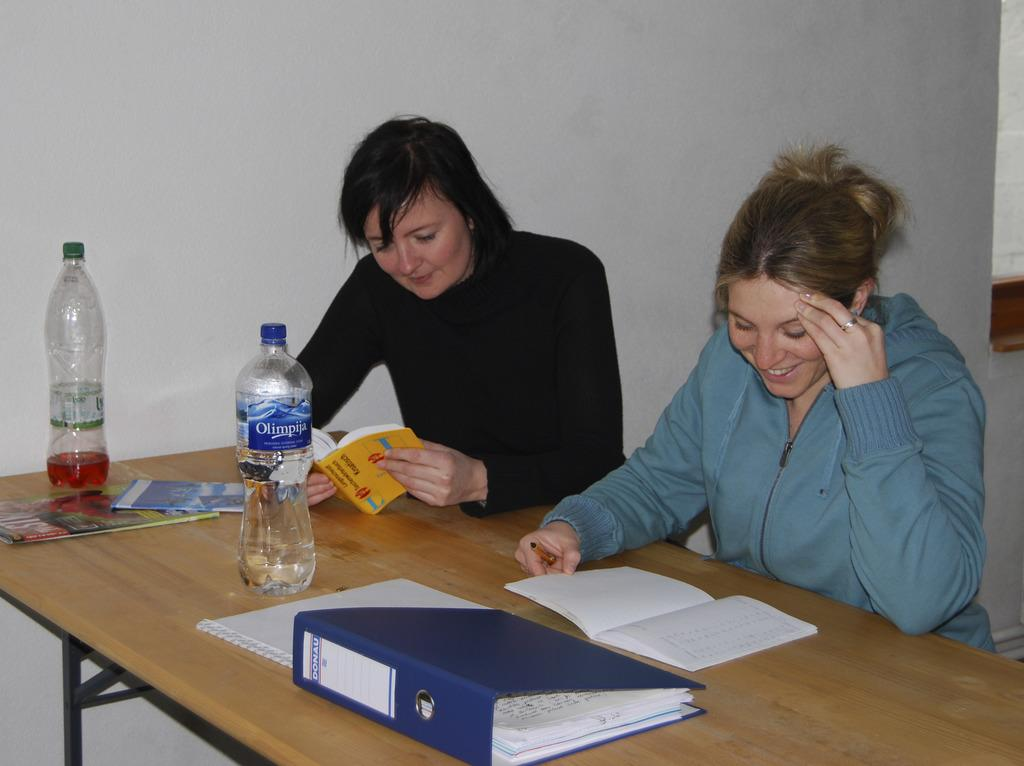How many women are present in the image? There are two women in the image. What are the women doing in the image? The women are sitting in front of a table. What objects can be seen on the table? There are two bottles and a file on the table. What is the facial expression of the women in the image? The women are smiling. In which direction are the women facing in the image? The provided facts do not specify the direction the women are facing in the image. --- 